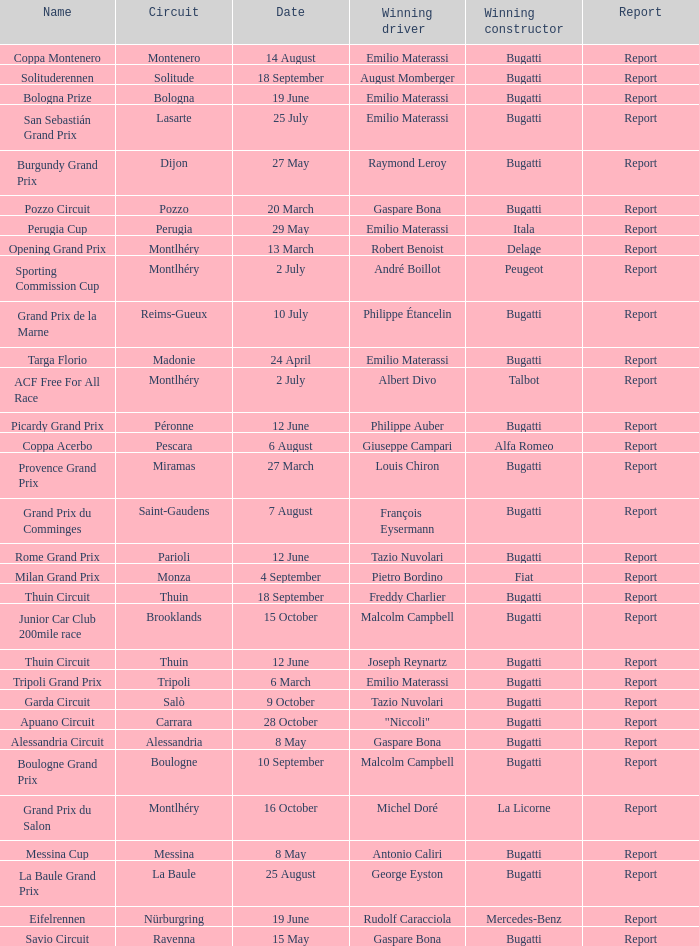Which circuit did françois eysermann win ? Saint-Gaudens. 